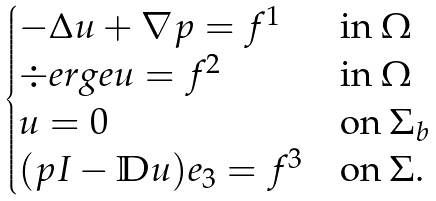<formula> <loc_0><loc_0><loc_500><loc_500>\begin{cases} - \Delta u + \nabla p = f ^ { 1 } & \text {in } \Omega \\ \div e r g e u = f ^ { 2 } & \text {in } \Omega \\ u = 0 & \text {on } \Sigma _ { b } \\ ( p I - \mathbb { D } u ) e _ { 3 } = f ^ { 3 } & \text {on } \Sigma . \end{cases}</formula> 